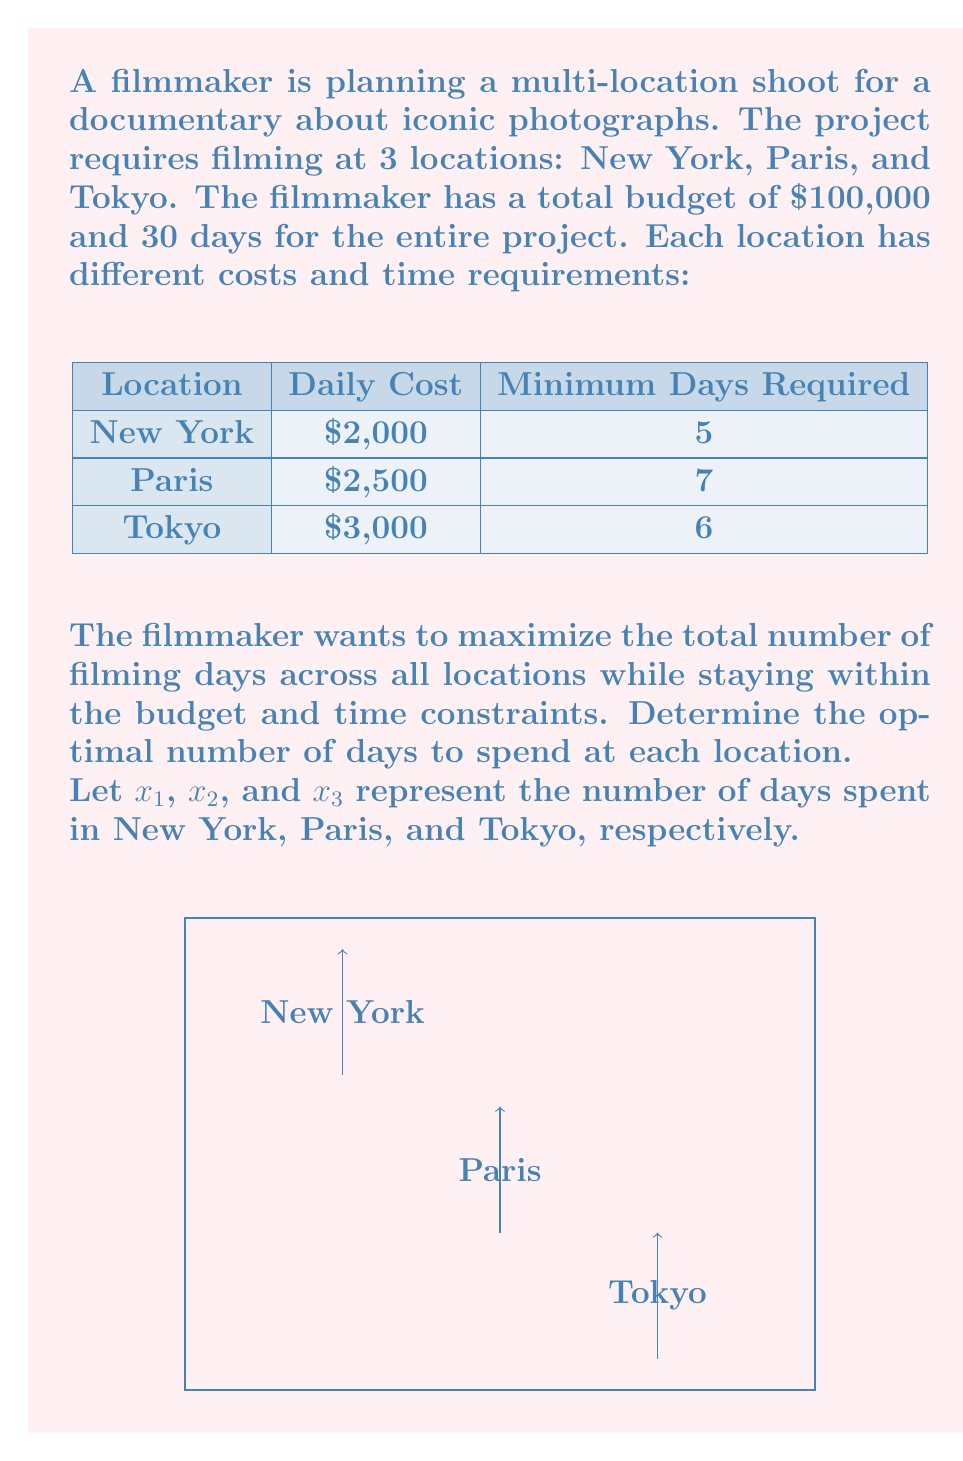Solve this math problem. To solve this problem, we'll use linear programming. We need to set up the objective function and constraints based on the given information.

Objective function:
Maximize $Z = x_1 + x_2 + x_3$

Constraints:
1. Budget constraint: $2000x_1 + 2500x_2 + 3000x_3 \leq 100000$
2. Time constraint: $x_1 + x_2 + x_3 \leq 30$
3. Minimum days for each location:
   $x_1 \geq 5$
   $x_2 \geq 7$
   $x_3 \geq 6$
4. Non-negativity: $x_1, x_2, x_3 \geq 0$

We can solve this using the simplex method or linear programming software. However, we can also reason through the solution:

1. Start by allocating the minimum required days to each location:
   New York: 5 days, Paris: 7 days, Tokyo: 6 days
   Total days: 18, Remaining days: 12, Remaining budget: $55,500

2. Allocate the remaining days to the cheapest location first (New York), then move to the next cheapest:
   New York: +12 days (total 17 days)
   Total days: 30, Remaining budget: $31,500

3. We've reached the time constraint (30 days), so we stop here.

4. Check if the solution satisfies all constraints:
   - Budget: $(2000 * 17) + (2500 * 7) + (3000 * 6) = 34000 + 17500 + 18000 = 69500 \leq 100000$
   - Time: $17 + 7 + 6 = 30 \leq 30$
   - Minimum days: All satisfied
   - Non-negativity: All satisfied

Therefore, the optimal solution is:
New York: 17 days
Paris: 7 days
Tokyo: 6 days
Answer: $x_1 = 17, x_2 = 7, x_3 = 6$ 